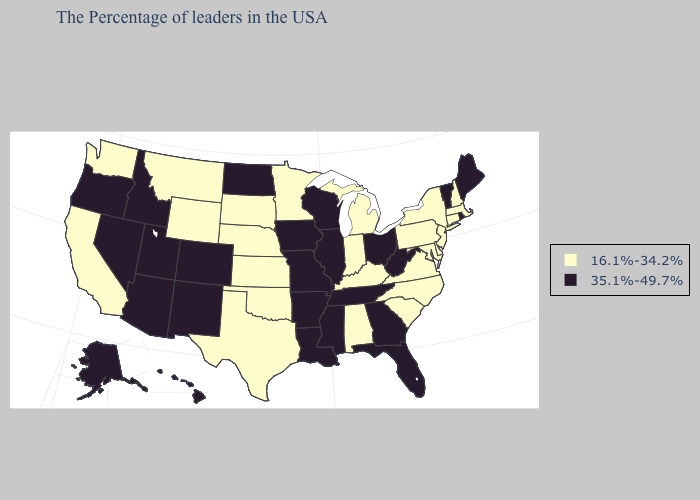Does the map have missing data?
Keep it brief. No. What is the highest value in the MidWest ?
Be succinct. 35.1%-49.7%. What is the highest value in the USA?
Give a very brief answer. 35.1%-49.7%. What is the value of Florida?
Be succinct. 35.1%-49.7%. What is the lowest value in states that border Kentucky?
Write a very short answer. 16.1%-34.2%. Name the states that have a value in the range 35.1%-49.7%?
Short answer required. Maine, Rhode Island, Vermont, West Virginia, Ohio, Florida, Georgia, Tennessee, Wisconsin, Illinois, Mississippi, Louisiana, Missouri, Arkansas, Iowa, North Dakota, Colorado, New Mexico, Utah, Arizona, Idaho, Nevada, Oregon, Alaska, Hawaii. Does Tennessee have the lowest value in the South?
Short answer required. No. What is the lowest value in the USA?
Answer briefly. 16.1%-34.2%. Name the states that have a value in the range 35.1%-49.7%?
Write a very short answer. Maine, Rhode Island, Vermont, West Virginia, Ohio, Florida, Georgia, Tennessee, Wisconsin, Illinois, Mississippi, Louisiana, Missouri, Arkansas, Iowa, North Dakota, Colorado, New Mexico, Utah, Arizona, Idaho, Nevada, Oregon, Alaska, Hawaii. Among the states that border Louisiana , does Texas have the lowest value?
Answer briefly. Yes. Name the states that have a value in the range 16.1%-34.2%?
Quick response, please. Massachusetts, New Hampshire, Connecticut, New York, New Jersey, Delaware, Maryland, Pennsylvania, Virginia, North Carolina, South Carolina, Michigan, Kentucky, Indiana, Alabama, Minnesota, Kansas, Nebraska, Oklahoma, Texas, South Dakota, Wyoming, Montana, California, Washington. Name the states that have a value in the range 16.1%-34.2%?
Answer briefly. Massachusetts, New Hampshire, Connecticut, New York, New Jersey, Delaware, Maryland, Pennsylvania, Virginia, North Carolina, South Carolina, Michigan, Kentucky, Indiana, Alabama, Minnesota, Kansas, Nebraska, Oklahoma, Texas, South Dakota, Wyoming, Montana, California, Washington. What is the value of Florida?
Write a very short answer. 35.1%-49.7%. How many symbols are there in the legend?
Be succinct. 2. What is the value of Kentucky?
Short answer required. 16.1%-34.2%. 